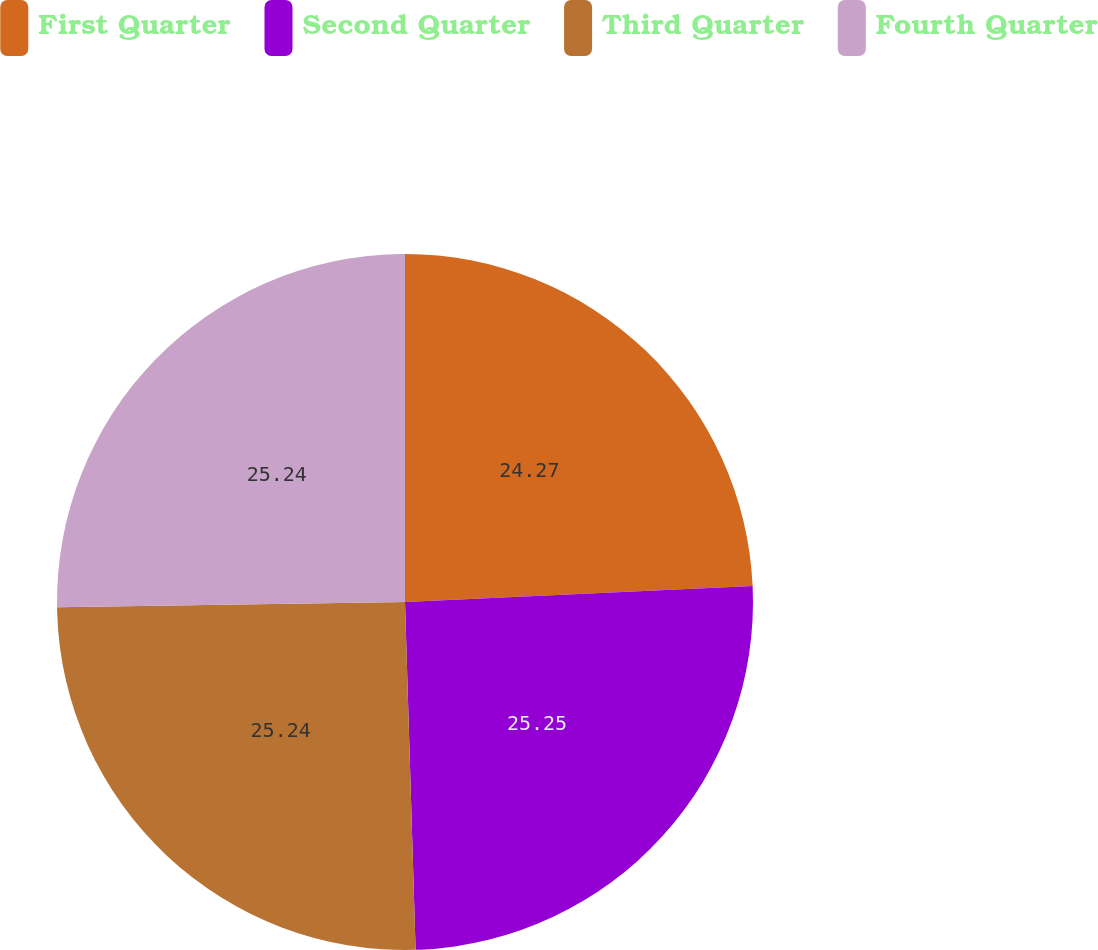Convert chart to OTSL. <chart><loc_0><loc_0><loc_500><loc_500><pie_chart><fcel>First Quarter<fcel>Second Quarter<fcel>Third Quarter<fcel>Fourth Quarter<nl><fcel>24.27%<fcel>25.24%<fcel>25.24%<fcel>25.24%<nl></chart> 